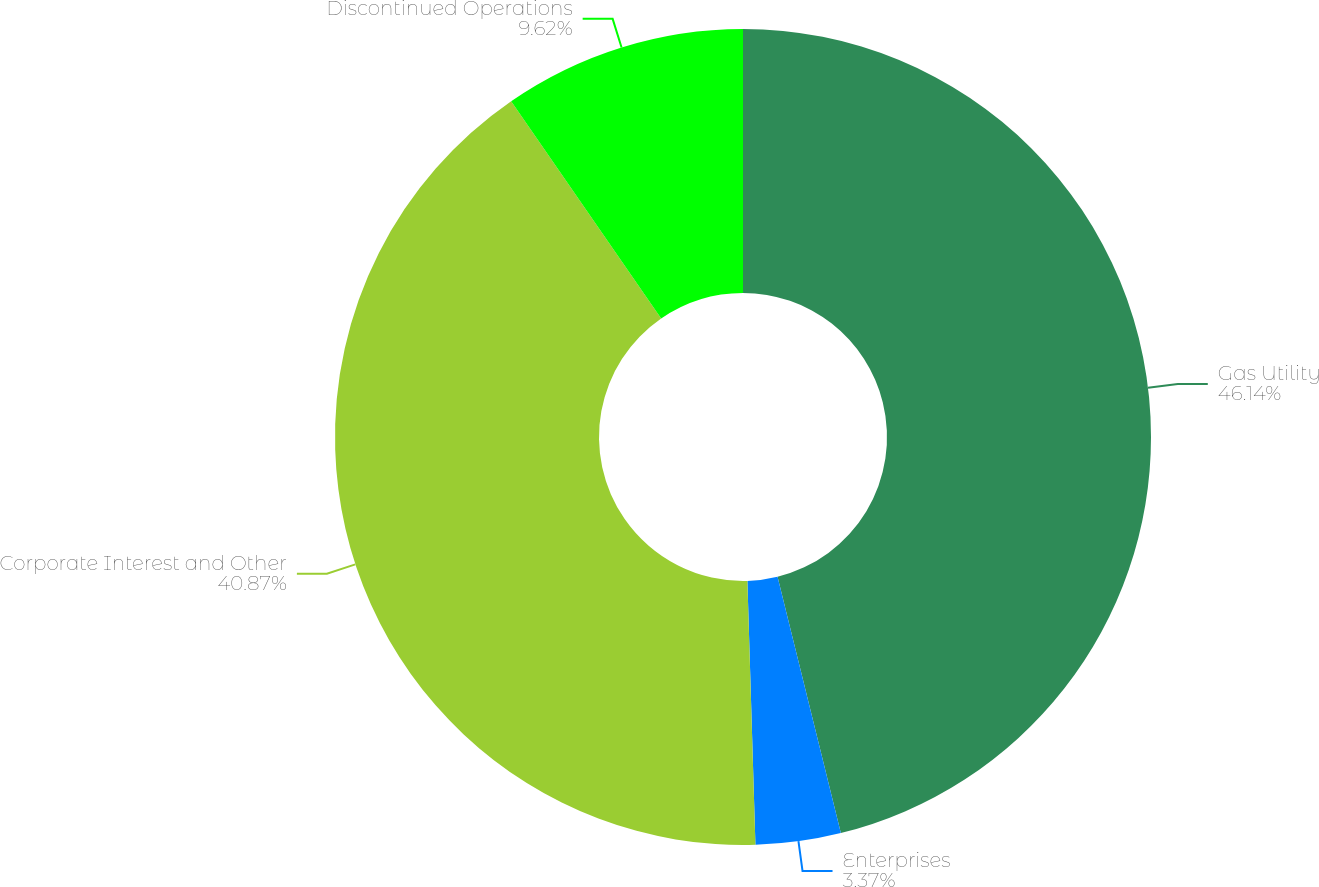Convert chart. <chart><loc_0><loc_0><loc_500><loc_500><pie_chart><fcel>Gas Utility<fcel>Enterprises<fcel>Corporate Interest and Other<fcel>Discontinued Operations<nl><fcel>46.15%<fcel>3.37%<fcel>40.87%<fcel>9.62%<nl></chart> 